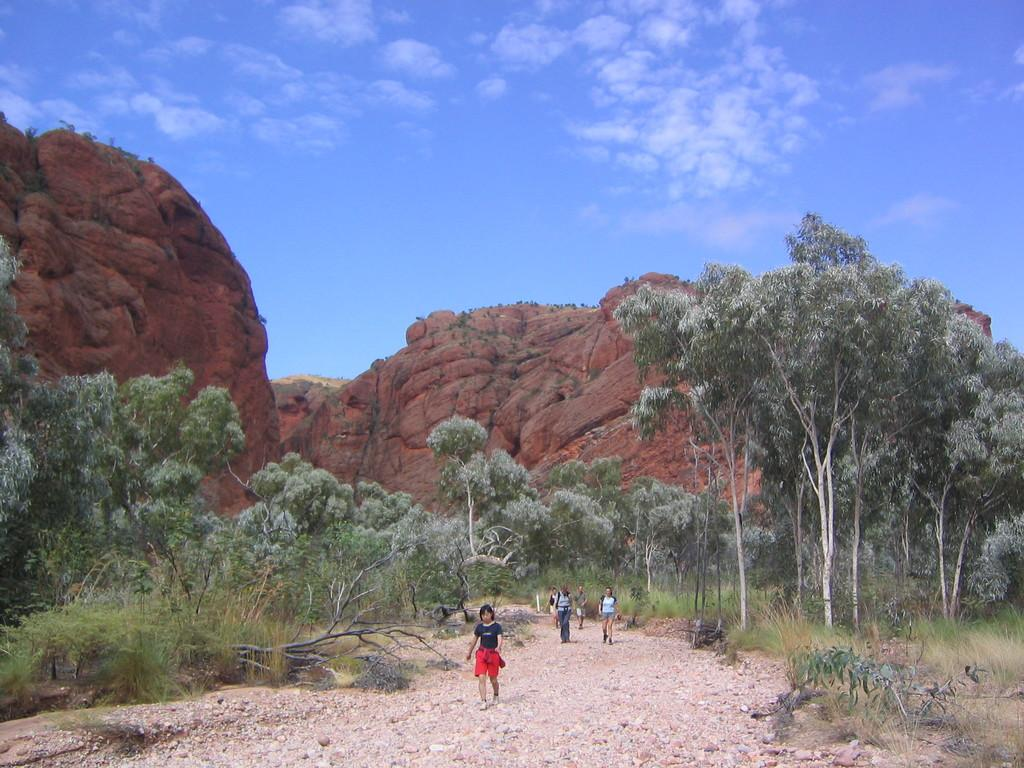What is happening on the ground in the image? There are people on the ground in the image. What can be seen in the background of the image? There are trees and rocks in the background of the image. What is visible in the sky in the image? The sky is visible in the background of the image, and clouds are present. Can you tell me how many fairies are sitting on the rocks in the image? There are no fairies present in the image; it features people, trees, rocks, and clouds. What grade is the person on the ground in the image? The provided facts do not mention any grades or levels of education, so it is not possible to determine the grade of the person in the image. 